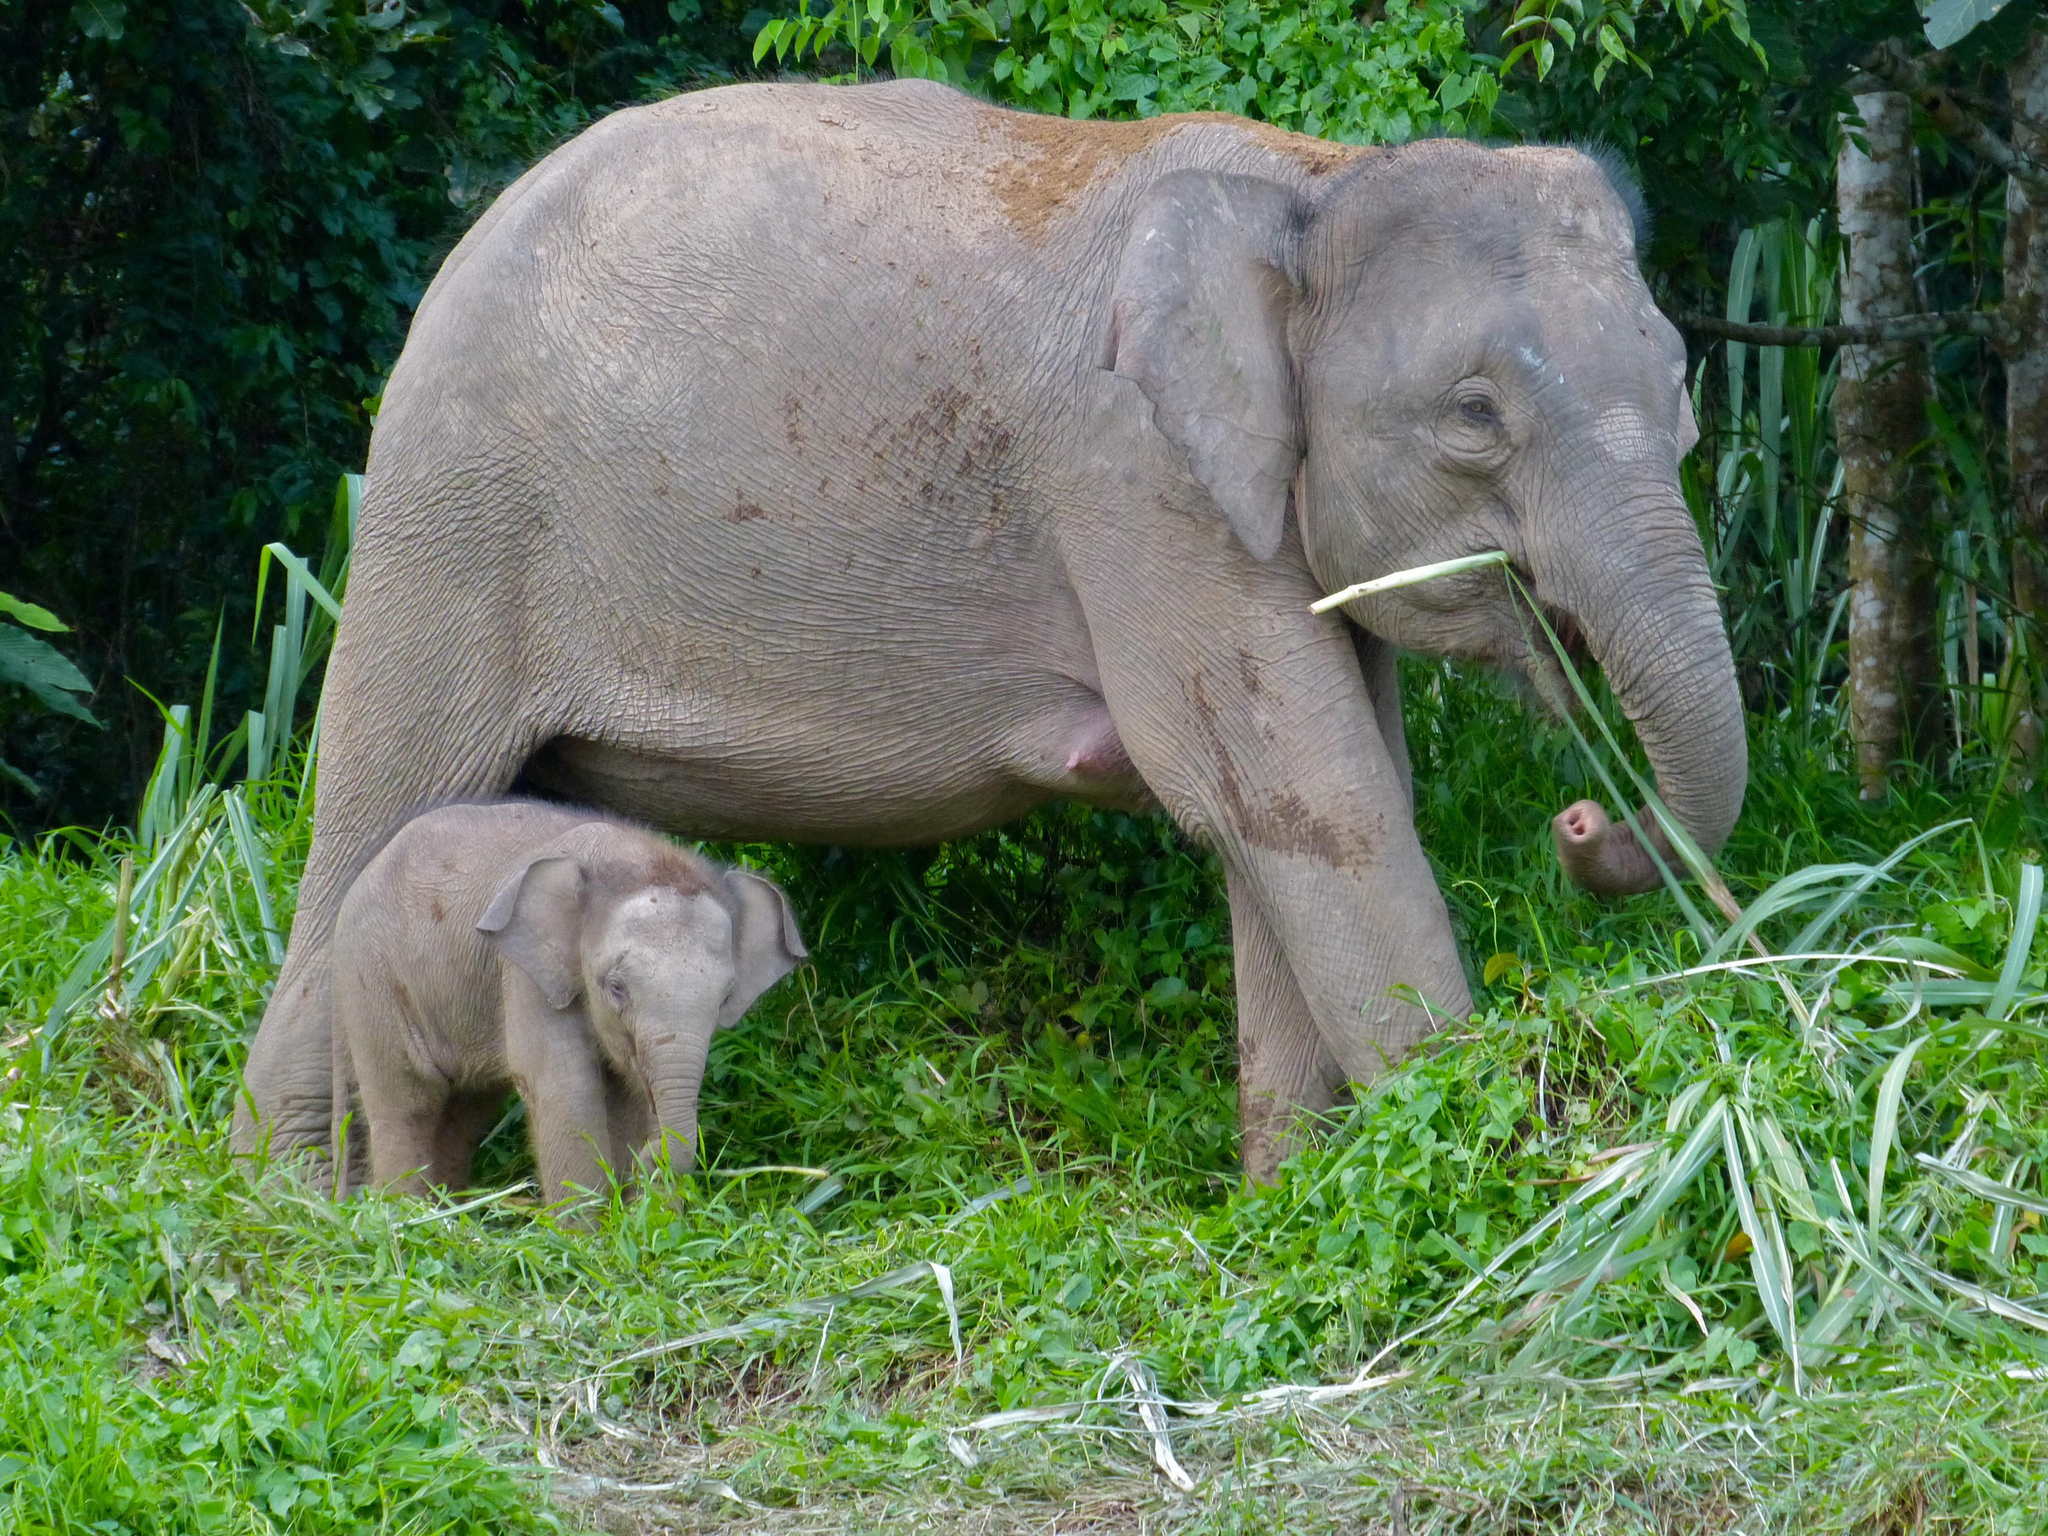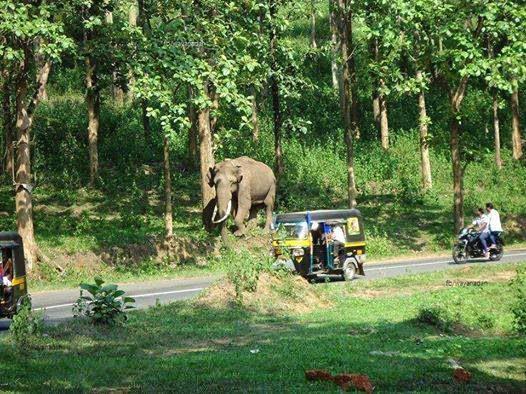The first image is the image on the left, the second image is the image on the right. Evaluate the accuracy of this statement regarding the images: "The right image shows an elephant with large tusks.". Is it true? Answer yes or no. Yes. 